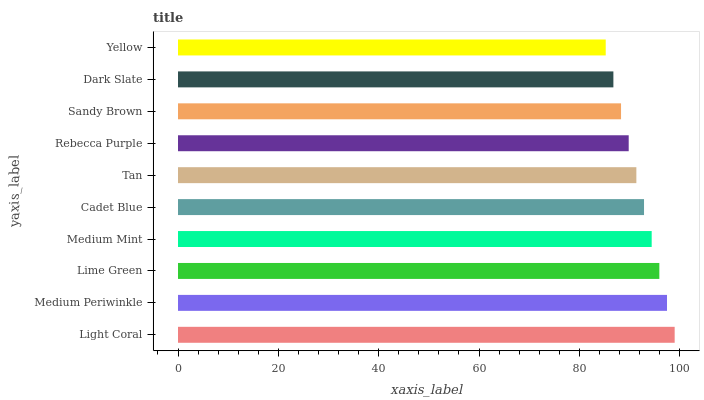Is Yellow the minimum?
Answer yes or no. Yes. Is Light Coral the maximum?
Answer yes or no. Yes. Is Medium Periwinkle the minimum?
Answer yes or no. No. Is Medium Periwinkle the maximum?
Answer yes or no. No. Is Light Coral greater than Medium Periwinkle?
Answer yes or no. Yes. Is Medium Periwinkle less than Light Coral?
Answer yes or no. Yes. Is Medium Periwinkle greater than Light Coral?
Answer yes or no. No. Is Light Coral less than Medium Periwinkle?
Answer yes or no. No. Is Cadet Blue the high median?
Answer yes or no. Yes. Is Tan the low median?
Answer yes or no. Yes. Is Sandy Brown the high median?
Answer yes or no. No. Is Rebecca Purple the low median?
Answer yes or no. No. 